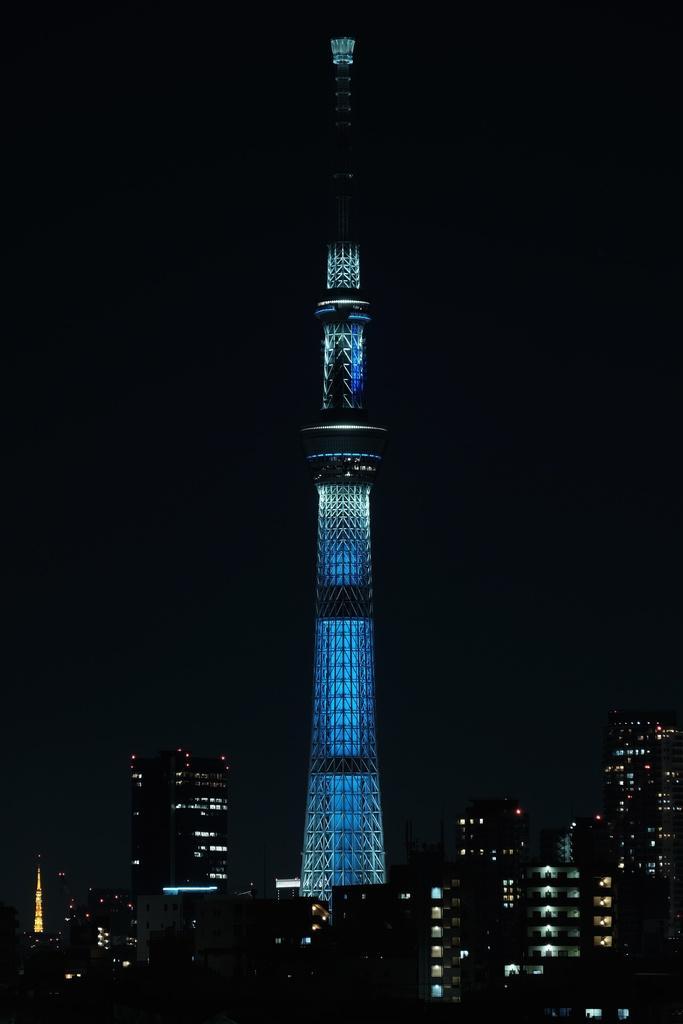Describe this image in one or two sentences. In this image we can see a tower with lights. At the bottom we can see a group of buildings. The background of the image is dark. 